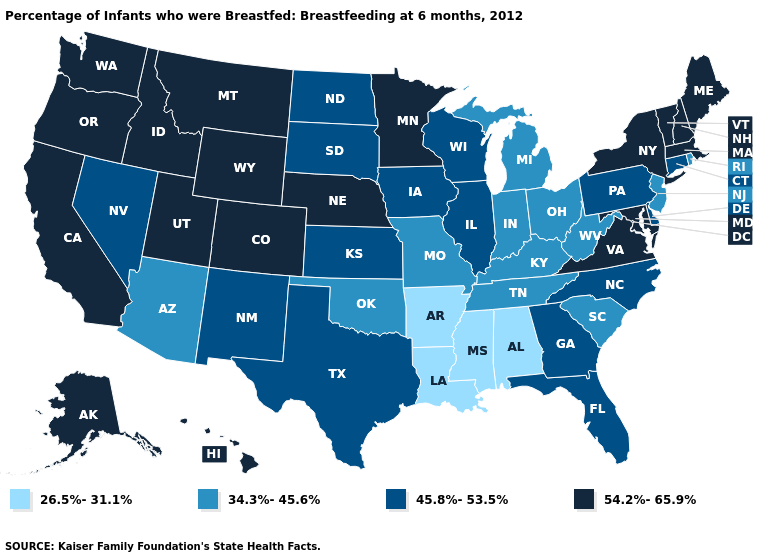Does the map have missing data?
Short answer required. No. What is the lowest value in the MidWest?
Short answer required. 34.3%-45.6%. What is the highest value in states that border Texas?
Answer briefly. 45.8%-53.5%. What is the lowest value in states that border California?
Answer briefly. 34.3%-45.6%. What is the value of Illinois?
Quick response, please. 45.8%-53.5%. Does Hawaii have the highest value in the USA?
Quick response, please. Yes. What is the value of Minnesota?
Keep it brief. 54.2%-65.9%. Name the states that have a value in the range 26.5%-31.1%?
Quick response, please. Alabama, Arkansas, Louisiana, Mississippi. Does Arkansas have the lowest value in the USA?
Write a very short answer. Yes. Does New York have the highest value in the USA?
Quick response, please. Yes. Among the states that border New York , which have the highest value?
Concise answer only. Massachusetts, Vermont. What is the highest value in the South ?
Keep it brief. 54.2%-65.9%. What is the lowest value in the South?
Keep it brief. 26.5%-31.1%. What is the value of Iowa?
Concise answer only. 45.8%-53.5%. What is the lowest value in the USA?
Short answer required. 26.5%-31.1%. 